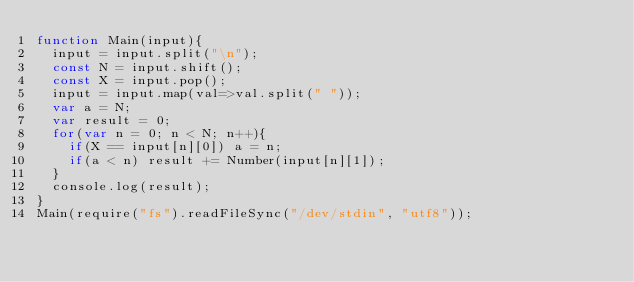<code> <loc_0><loc_0><loc_500><loc_500><_JavaScript_>function Main(input){
  input = input.split("\n");
  const N = input.shift();
  const X = input.pop();
  input = input.map(val=>val.split(" "));
  var a = N;
  var result = 0;
  for(var n = 0; n < N; n++){
    if(X == input[n][0]) a = n;
    if(a < n) result += Number(input[n][1]);
  }
  console.log(result);
}
Main(require("fs").readFileSync("/dev/stdin", "utf8"));</code> 